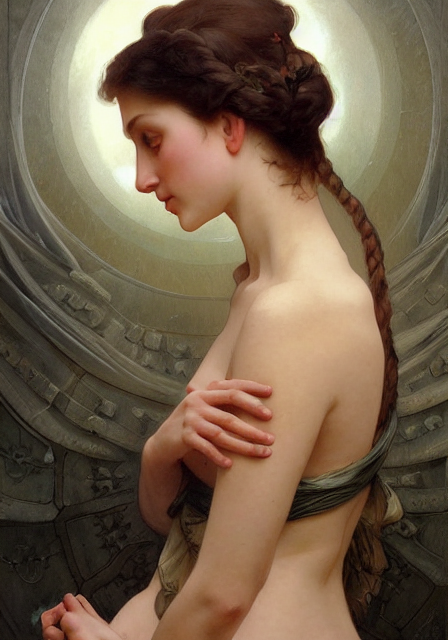What emotions does the subject of the image evoke? The subject exudes a sense of tranquility and introspection, with a gentle, downward gaze that suggests a moment of quiet contemplation or inner peace. 